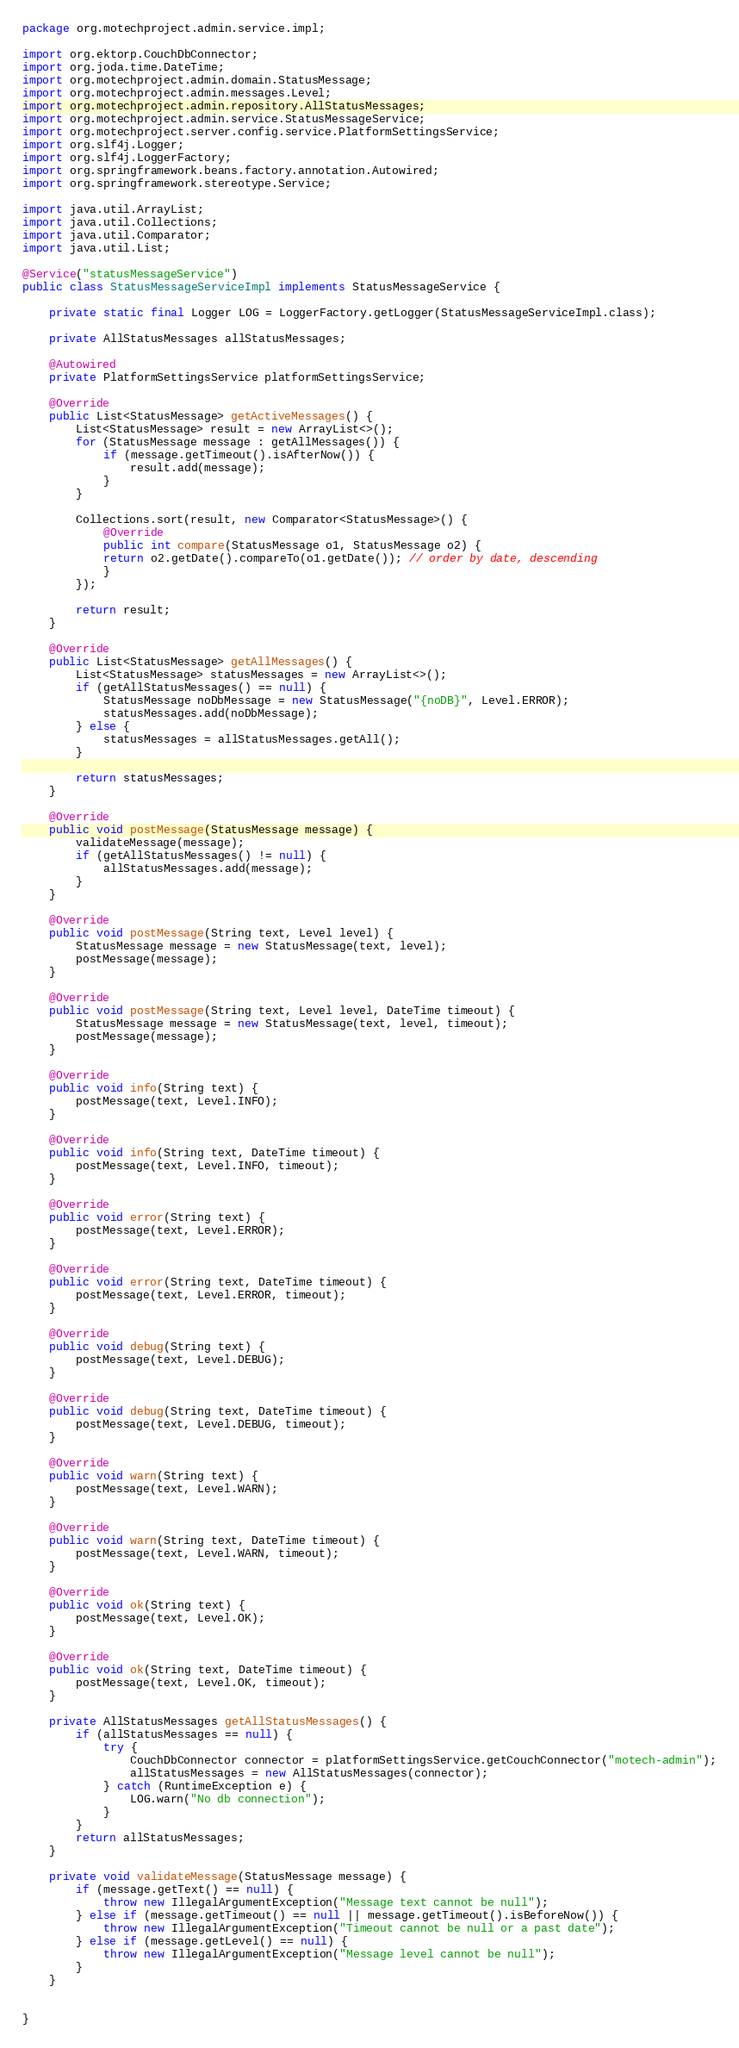Convert code to text. <code><loc_0><loc_0><loc_500><loc_500><_Java_>package org.motechproject.admin.service.impl;

import org.ektorp.CouchDbConnector;
import org.joda.time.DateTime;
import org.motechproject.admin.domain.StatusMessage;
import org.motechproject.admin.messages.Level;
import org.motechproject.admin.repository.AllStatusMessages;
import org.motechproject.admin.service.StatusMessageService;
import org.motechproject.server.config.service.PlatformSettingsService;
import org.slf4j.Logger;
import org.slf4j.LoggerFactory;
import org.springframework.beans.factory.annotation.Autowired;
import org.springframework.stereotype.Service;

import java.util.ArrayList;
import java.util.Collections;
import java.util.Comparator;
import java.util.List;

@Service("statusMessageService")
public class StatusMessageServiceImpl implements StatusMessageService {

    private static final Logger LOG = LoggerFactory.getLogger(StatusMessageServiceImpl.class);

    private AllStatusMessages allStatusMessages;

    @Autowired
    private PlatformSettingsService platformSettingsService;

    @Override
    public List<StatusMessage> getActiveMessages() {
        List<StatusMessage> result = new ArrayList<>();
        for (StatusMessage message : getAllMessages()) {
            if (message.getTimeout().isAfterNow()) {
                result.add(message);
            }
        }

        Collections.sort(result, new Comparator<StatusMessage>() {
            @Override
            public int compare(StatusMessage o1, StatusMessage o2) {
            return o2.getDate().compareTo(o1.getDate()); // order by date, descending
            }
        });

        return result;
    }

    @Override
    public List<StatusMessage> getAllMessages() {
        List<StatusMessage> statusMessages = new ArrayList<>();
        if (getAllStatusMessages() == null) {
            StatusMessage noDbMessage = new StatusMessage("{noDB}", Level.ERROR);
            statusMessages.add(noDbMessage);
        } else {
            statusMessages = allStatusMessages.getAll();
        }

        return statusMessages;
    }

    @Override
    public void postMessage(StatusMessage message) {
        validateMessage(message);
        if (getAllStatusMessages() != null) {
            allStatusMessages.add(message);
        }
    }

    @Override
    public void postMessage(String text, Level level) {
        StatusMessage message = new StatusMessage(text, level);
        postMessage(message);
    }

    @Override
    public void postMessage(String text, Level level, DateTime timeout) {
        StatusMessage message = new StatusMessage(text, level, timeout);
        postMessage(message);
    }

    @Override
    public void info(String text) {
        postMessage(text, Level.INFO);
    }

    @Override
    public void info(String text, DateTime timeout) {
        postMessage(text, Level.INFO, timeout);
    }

    @Override
    public void error(String text) {
        postMessage(text, Level.ERROR);
    }

    @Override
    public void error(String text, DateTime timeout) {
        postMessage(text, Level.ERROR, timeout);
    }

    @Override
    public void debug(String text) {
        postMessage(text, Level.DEBUG);
    }

    @Override
    public void debug(String text, DateTime timeout) {
        postMessage(text, Level.DEBUG, timeout);
    }

    @Override
    public void warn(String text) {
        postMessage(text, Level.WARN);
    }

    @Override
    public void warn(String text, DateTime timeout) {
        postMessage(text, Level.WARN, timeout);
    }

    @Override
    public void ok(String text) {
        postMessage(text, Level.OK);
    }

    @Override
    public void ok(String text, DateTime timeout) {
        postMessage(text, Level.OK, timeout);
    }

    private AllStatusMessages getAllStatusMessages() {
        if (allStatusMessages == null) {
            try {
                CouchDbConnector connector = platformSettingsService.getCouchConnector("motech-admin");
                allStatusMessages = new AllStatusMessages(connector);
            } catch (RuntimeException e) {
                LOG.warn("No db connection");
            }
        }
        return allStatusMessages;
    }

    private void validateMessage(StatusMessage message) {
        if (message.getText() == null) {
            throw new IllegalArgumentException("Message text cannot be null");
        } else if (message.getTimeout() == null || message.getTimeout().isBeforeNow()) {
            throw new IllegalArgumentException("Timeout cannot be null or a past date");
        } else if (message.getLevel() == null) {
            throw new IllegalArgumentException("Message level cannot be null");
        }
    }


}
</code> 